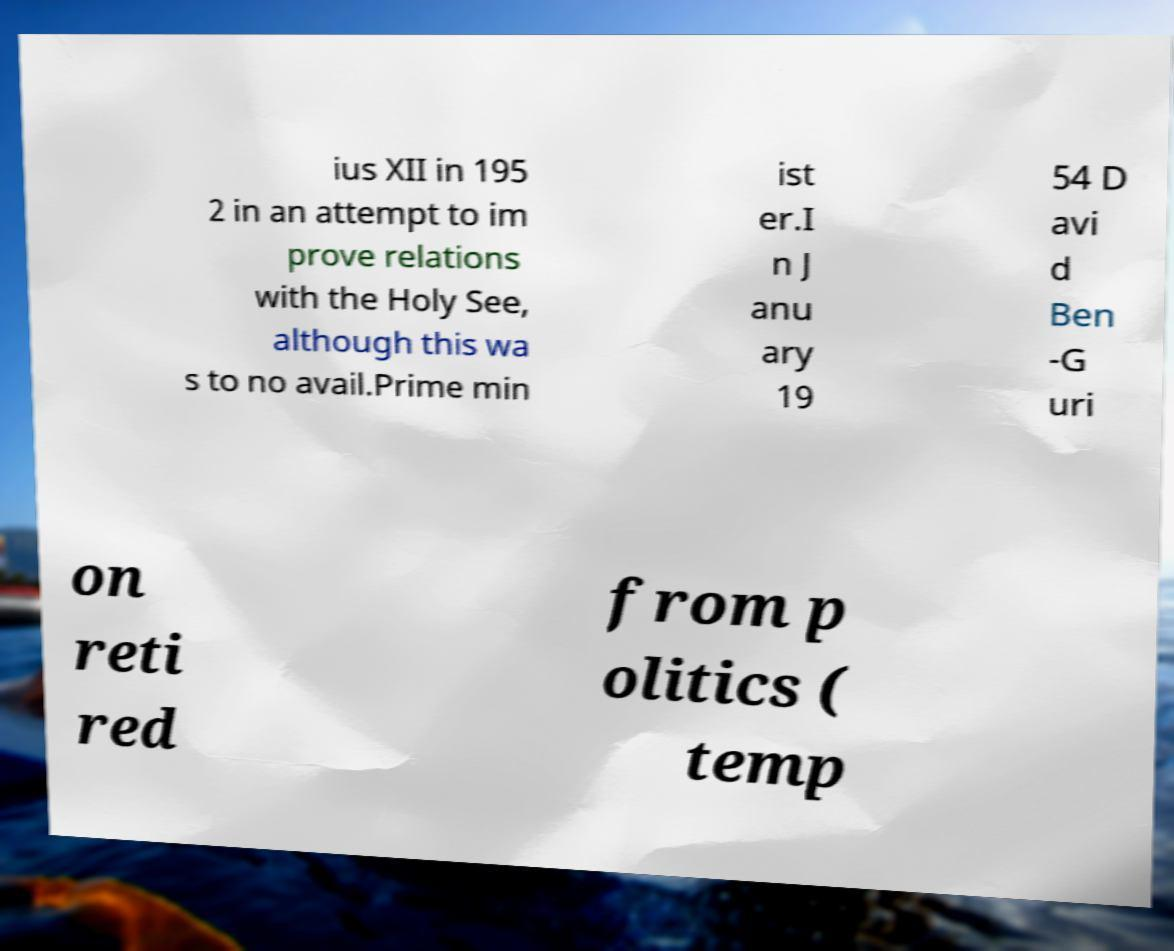I need the written content from this picture converted into text. Can you do that? ius XII in 195 2 in an attempt to im prove relations with the Holy See, although this wa s to no avail.Prime min ist er.I n J anu ary 19 54 D avi d Ben -G uri on reti red from p olitics ( temp 